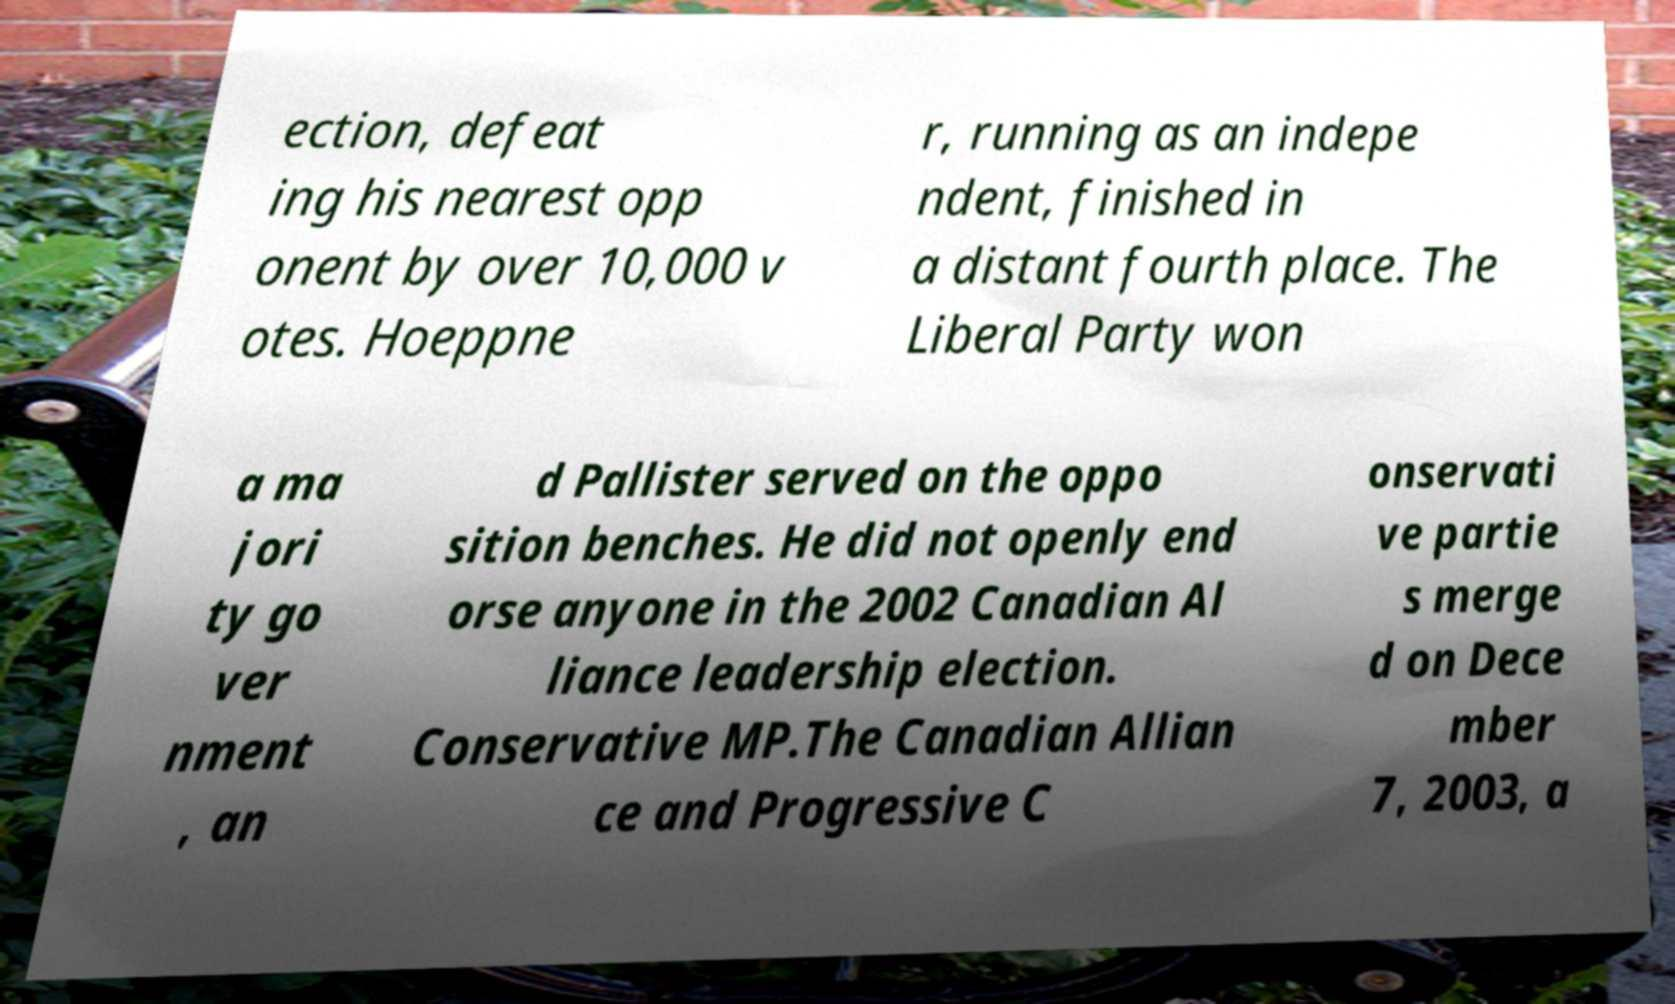Please identify and transcribe the text found in this image. ection, defeat ing his nearest opp onent by over 10,000 v otes. Hoeppne r, running as an indepe ndent, finished in a distant fourth place. The Liberal Party won a ma jori ty go ver nment , an d Pallister served on the oppo sition benches. He did not openly end orse anyone in the 2002 Canadian Al liance leadership election. Conservative MP.The Canadian Allian ce and Progressive C onservati ve partie s merge d on Dece mber 7, 2003, a 